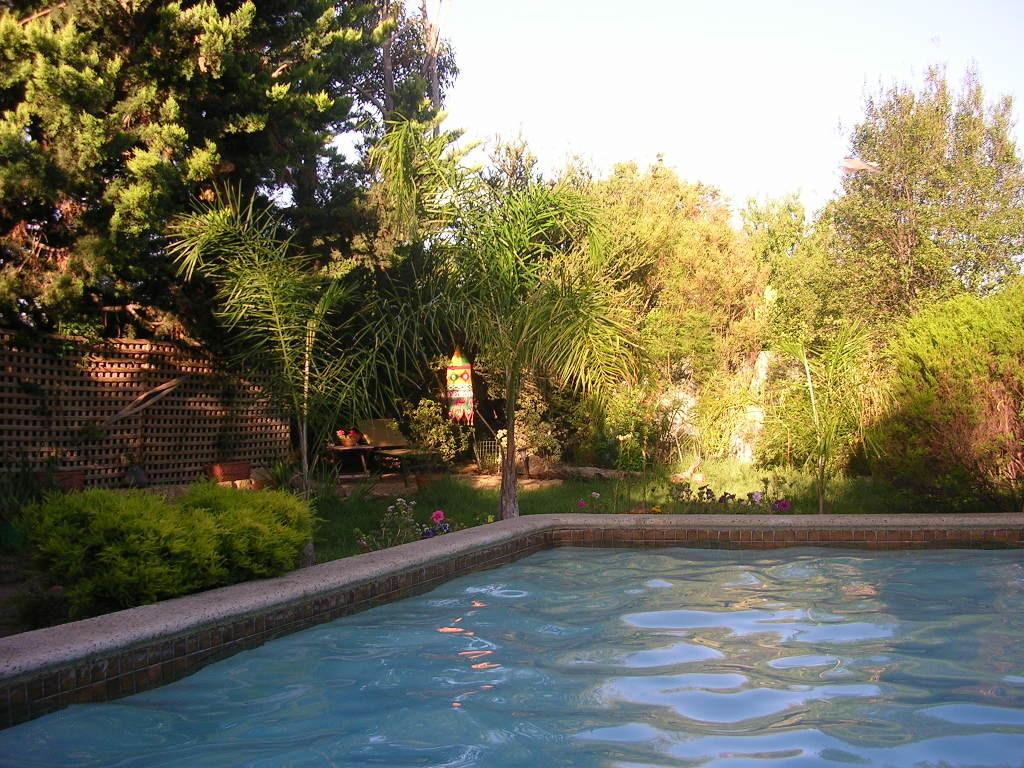What is present in the pond in the image? There is water in the pond in the image. What type of vegetation can be seen in the image? There are plants and flowers in the image. What material are some of the objects made of in the image? There are wooden objects in the image. Can you describe any other objects in the image? There are other objects in the image, but their specific details are not mentioned in the provided facts. What is visible in the background of the image? The sky is visible in the image. What type of brick structure can be seen in the image? There is no brick structure present in the image. What type of lumber is being used to build the office in the image? There is no office or lumber present in the image. 